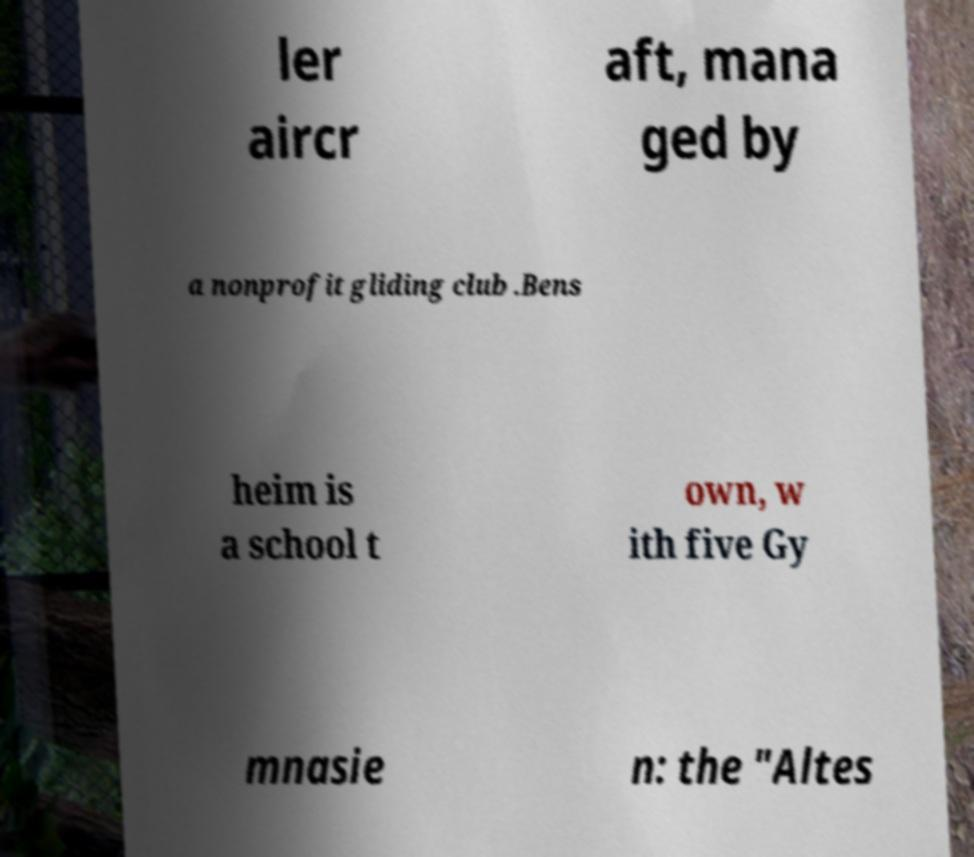Please read and relay the text visible in this image. What does it say? ler aircr aft, mana ged by a nonprofit gliding club .Bens heim is a school t own, w ith five Gy mnasie n: the "Altes 